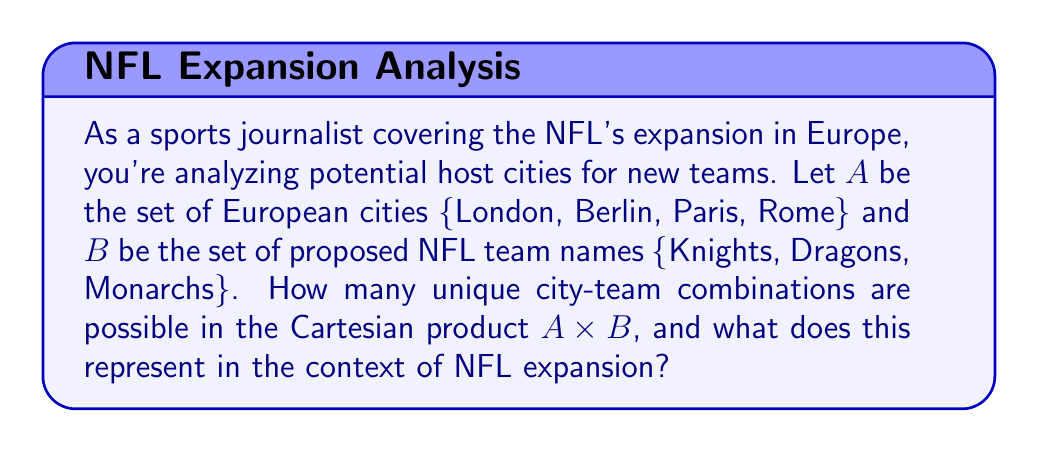What is the answer to this math problem? To solve this problem, we need to understand the concept of Cartesian product and its application to the given scenario.

1. Cartesian product definition:
   The Cartesian product of two sets A and B, denoted as A × B, is the set of all ordered pairs (a, b) where a ∈ A and b ∈ B.

2. Given sets:
   A = {London, Berlin, Paris, Rome}
   B = {Knights, Dragons, Monarchs}

3. Calculate the number of elements in each set:
   |A| = 4 (number of cities)
   |B| = 3 (number of team names)

4. The number of elements in the Cartesian product A × B is given by:
   |A × B| = |A| × |B|

5. Substituting the values:
   |A × B| = 4 × 3 = 12

6. List all possible combinations:
   (London, Knights), (London, Dragons), (London, Monarchs)
   (Berlin, Knights), (Berlin, Dragons), (Berlin, Monarchs)
   (Paris, Knights), (Paris, Dragons), (Paris, Monarchs)
   (Rome, Knights), (Rome, Dragons), (Rome, Monarchs)

In the context of NFL expansion, each of these 12 combinations represents a potential new NFL team in a European city. For example, (London, Knights) could represent the London Knights NFL team.
Answer: The Cartesian product A × B contains 12 unique city-team combinations, representing all possible new NFL teams in the given European cities. 